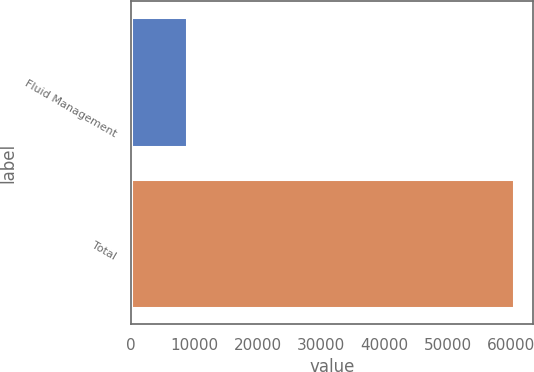Convert chart to OTSL. <chart><loc_0><loc_0><loc_500><loc_500><bar_chart><fcel>Fluid Management<fcel>Total<nl><fcel>8814<fcel>60556<nl></chart> 